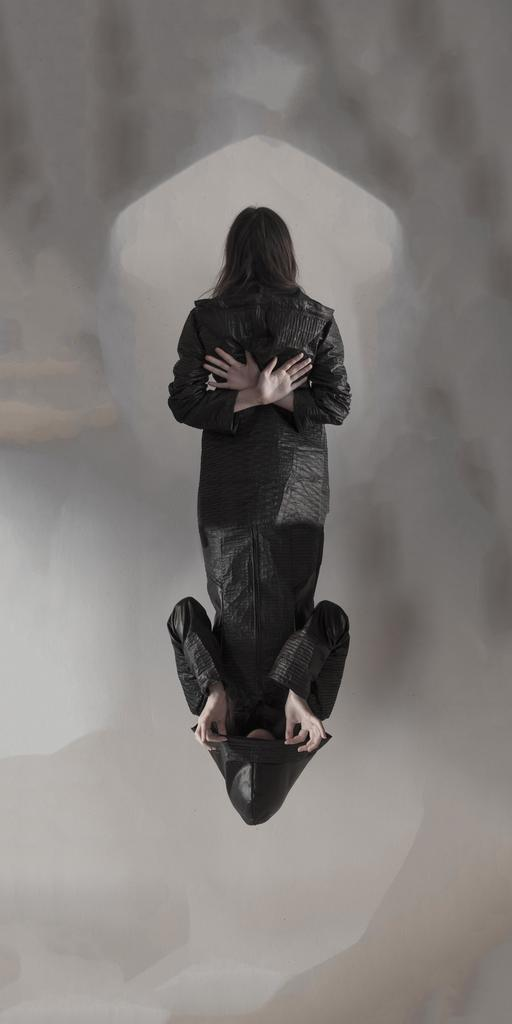What type of image is being described? The image is graphical in nature. How many people are depicted in the image? There are two persons in the image. How many cats can be seen playing with a rock in the image? There are no cats or rocks present in the image; it only features two persons. 